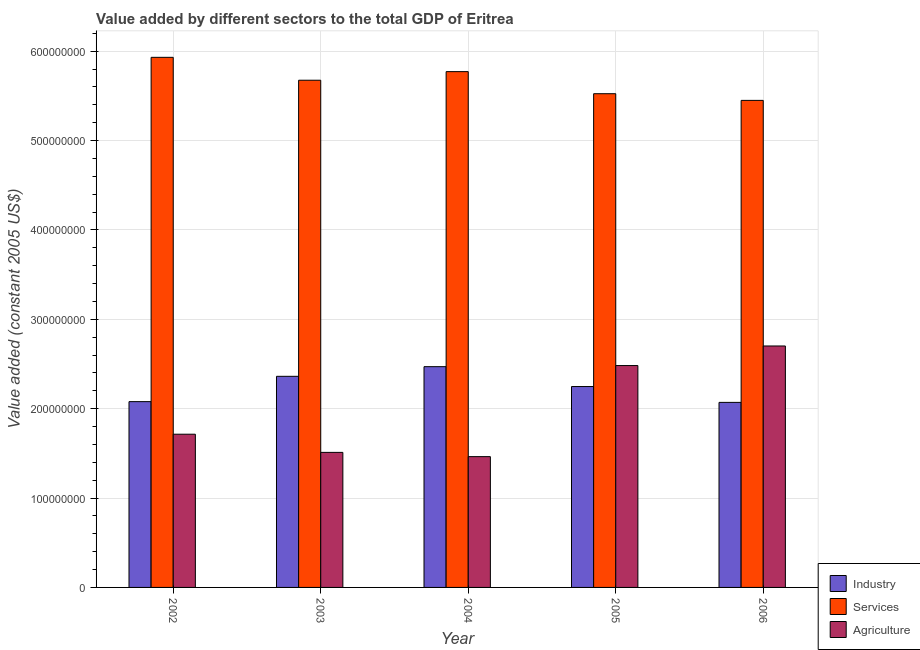How many groups of bars are there?
Give a very brief answer. 5. Are the number of bars per tick equal to the number of legend labels?
Your answer should be very brief. Yes. How many bars are there on the 1st tick from the right?
Offer a very short reply. 3. What is the value added by services in 2003?
Provide a succinct answer. 5.67e+08. Across all years, what is the maximum value added by services?
Your answer should be very brief. 5.93e+08. Across all years, what is the minimum value added by industrial sector?
Keep it short and to the point. 2.07e+08. In which year was the value added by industrial sector maximum?
Keep it short and to the point. 2004. What is the total value added by services in the graph?
Offer a terse response. 2.84e+09. What is the difference between the value added by agricultural sector in 2005 and that in 2006?
Your answer should be very brief. -2.19e+07. What is the difference between the value added by industrial sector in 2003 and the value added by agricultural sector in 2002?
Offer a terse response. 2.83e+07. What is the average value added by industrial sector per year?
Provide a succinct answer. 2.25e+08. In the year 2002, what is the difference between the value added by agricultural sector and value added by services?
Offer a terse response. 0. In how many years, is the value added by industrial sector greater than 320000000 US$?
Ensure brevity in your answer.  0. What is the ratio of the value added by agricultural sector in 2002 to that in 2005?
Keep it short and to the point. 0.69. Is the difference between the value added by agricultural sector in 2004 and 2005 greater than the difference between the value added by industrial sector in 2004 and 2005?
Keep it short and to the point. No. What is the difference between the highest and the second highest value added by industrial sector?
Provide a short and direct response. 1.08e+07. What is the difference between the highest and the lowest value added by agricultural sector?
Your response must be concise. 1.24e+08. What does the 1st bar from the left in 2004 represents?
Your answer should be compact. Industry. What does the 3rd bar from the right in 2005 represents?
Keep it short and to the point. Industry. Is it the case that in every year, the sum of the value added by industrial sector and value added by services is greater than the value added by agricultural sector?
Keep it short and to the point. Yes. Are all the bars in the graph horizontal?
Your answer should be very brief. No. What is the difference between two consecutive major ticks on the Y-axis?
Offer a terse response. 1.00e+08. Are the values on the major ticks of Y-axis written in scientific E-notation?
Keep it short and to the point. No. Does the graph contain any zero values?
Your response must be concise. No. Does the graph contain grids?
Ensure brevity in your answer.  Yes. Where does the legend appear in the graph?
Your answer should be compact. Bottom right. How many legend labels are there?
Provide a succinct answer. 3. How are the legend labels stacked?
Make the answer very short. Vertical. What is the title of the graph?
Offer a terse response. Value added by different sectors to the total GDP of Eritrea. What is the label or title of the X-axis?
Your answer should be compact. Year. What is the label or title of the Y-axis?
Offer a very short reply. Value added (constant 2005 US$). What is the Value added (constant 2005 US$) in Industry in 2002?
Offer a terse response. 2.08e+08. What is the Value added (constant 2005 US$) in Services in 2002?
Your answer should be very brief. 5.93e+08. What is the Value added (constant 2005 US$) of Agriculture in 2002?
Keep it short and to the point. 1.71e+08. What is the Value added (constant 2005 US$) in Industry in 2003?
Your answer should be very brief. 2.36e+08. What is the Value added (constant 2005 US$) of Services in 2003?
Ensure brevity in your answer.  5.67e+08. What is the Value added (constant 2005 US$) in Agriculture in 2003?
Your answer should be very brief. 1.51e+08. What is the Value added (constant 2005 US$) of Industry in 2004?
Offer a terse response. 2.47e+08. What is the Value added (constant 2005 US$) of Services in 2004?
Keep it short and to the point. 5.77e+08. What is the Value added (constant 2005 US$) of Agriculture in 2004?
Give a very brief answer. 1.46e+08. What is the Value added (constant 2005 US$) in Industry in 2005?
Ensure brevity in your answer.  2.25e+08. What is the Value added (constant 2005 US$) of Services in 2005?
Your answer should be very brief. 5.52e+08. What is the Value added (constant 2005 US$) in Agriculture in 2005?
Your answer should be very brief. 2.48e+08. What is the Value added (constant 2005 US$) in Industry in 2006?
Your answer should be compact. 2.07e+08. What is the Value added (constant 2005 US$) of Services in 2006?
Offer a very short reply. 5.45e+08. What is the Value added (constant 2005 US$) of Agriculture in 2006?
Keep it short and to the point. 2.70e+08. Across all years, what is the maximum Value added (constant 2005 US$) in Industry?
Make the answer very short. 2.47e+08. Across all years, what is the maximum Value added (constant 2005 US$) of Services?
Offer a terse response. 5.93e+08. Across all years, what is the maximum Value added (constant 2005 US$) in Agriculture?
Offer a terse response. 2.70e+08. Across all years, what is the minimum Value added (constant 2005 US$) of Industry?
Make the answer very short. 2.07e+08. Across all years, what is the minimum Value added (constant 2005 US$) of Services?
Provide a short and direct response. 5.45e+08. Across all years, what is the minimum Value added (constant 2005 US$) of Agriculture?
Keep it short and to the point. 1.46e+08. What is the total Value added (constant 2005 US$) in Industry in the graph?
Your answer should be compact. 1.12e+09. What is the total Value added (constant 2005 US$) of Services in the graph?
Your response must be concise. 2.84e+09. What is the total Value added (constant 2005 US$) of Agriculture in the graph?
Offer a terse response. 9.87e+08. What is the difference between the Value added (constant 2005 US$) of Industry in 2002 and that in 2003?
Keep it short and to the point. -2.83e+07. What is the difference between the Value added (constant 2005 US$) in Services in 2002 and that in 2003?
Keep it short and to the point. 2.56e+07. What is the difference between the Value added (constant 2005 US$) of Agriculture in 2002 and that in 2003?
Make the answer very short. 2.03e+07. What is the difference between the Value added (constant 2005 US$) of Industry in 2002 and that in 2004?
Your response must be concise. -3.91e+07. What is the difference between the Value added (constant 2005 US$) of Services in 2002 and that in 2004?
Ensure brevity in your answer.  1.60e+07. What is the difference between the Value added (constant 2005 US$) in Agriculture in 2002 and that in 2004?
Your response must be concise. 2.51e+07. What is the difference between the Value added (constant 2005 US$) in Industry in 2002 and that in 2005?
Your answer should be compact. -1.69e+07. What is the difference between the Value added (constant 2005 US$) of Services in 2002 and that in 2005?
Make the answer very short. 4.07e+07. What is the difference between the Value added (constant 2005 US$) of Agriculture in 2002 and that in 2005?
Your response must be concise. -7.68e+07. What is the difference between the Value added (constant 2005 US$) of Industry in 2002 and that in 2006?
Give a very brief answer. 8.30e+05. What is the difference between the Value added (constant 2005 US$) in Services in 2002 and that in 2006?
Your answer should be very brief. 4.82e+07. What is the difference between the Value added (constant 2005 US$) of Agriculture in 2002 and that in 2006?
Give a very brief answer. -9.87e+07. What is the difference between the Value added (constant 2005 US$) in Industry in 2003 and that in 2004?
Provide a short and direct response. -1.08e+07. What is the difference between the Value added (constant 2005 US$) in Services in 2003 and that in 2004?
Your answer should be very brief. -9.62e+06. What is the difference between the Value added (constant 2005 US$) in Agriculture in 2003 and that in 2004?
Your response must be concise. 4.76e+06. What is the difference between the Value added (constant 2005 US$) in Industry in 2003 and that in 2005?
Give a very brief answer. 1.14e+07. What is the difference between the Value added (constant 2005 US$) in Services in 2003 and that in 2005?
Offer a terse response. 1.51e+07. What is the difference between the Value added (constant 2005 US$) in Agriculture in 2003 and that in 2005?
Keep it short and to the point. -9.71e+07. What is the difference between the Value added (constant 2005 US$) of Industry in 2003 and that in 2006?
Your response must be concise. 2.92e+07. What is the difference between the Value added (constant 2005 US$) in Services in 2003 and that in 2006?
Your answer should be very brief. 2.26e+07. What is the difference between the Value added (constant 2005 US$) of Agriculture in 2003 and that in 2006?
Give a very brief answer. -1.19e+08. What is the difference between the Value added (constant 2005 US$) in Industry in 2004 and that in 2005?
Offer a very short reply. 2.22e+07. What is the difference between the Value added (constant 2005 US$) in Services in 2004 and that in 2005?
Ensure brevity in your answer.  2.47e+07. What is the difference between the Value added (constant 2005 US$) of Agriculture in 2004 and that in 2005?
Offer a very short reply. -1.02e+08. What is the difference between the Value added (constant 2005 US$) of Industry in 2004 and that in 2006?
Keep it short and to the point. 4.00e+07. What is the difference between the Value added (constant 2005 US$) in Services in 2004 and that in 2006?
Your response must be concise. 3.22e+07. What is the difference between the Value added (constant 2005 US$) of Agriculture in 2004 and that in 2006?
Your answer should be very brief. -1.24e+08. What is the difference between the Value added (constant 2005 US$) in Industry in 2005 and that in 2006?
Your response must be concise. 1.77e+07. What is the difference between the Value added (constant 2005 US$) in Services in 2005 and that in 2006?
Your answer should be compact. 7.46e+06. What is the difference between the Value added (constant 2005 US$) in Agriculture in 2005 and that in 2006?
Make the answer very short. -2.19e+07. What is the difference between the Value added (constant 2005 US$) of Industry in 2002 and the Value added (constant 2005 US$) of Services in 2003?
Ensure brevity in your answer.  -3.60e+08. What is the difference between the Value added (constant 2005 US$) in Industry in 2002 and the Value added (constant 2005 US$) in Agriculture in 2003?
Your answer should be very brief. 5.68e+07. What is the difference between the Value added (constant 2005 US$) of Services in 2002 and the Value added (constant 2005 US$) of Agriculture in 2003?
Your response must be concise. 4.42e+08. What is the difference between the Value added (constant 2005 US$) of Industry in 2002 and the Value added (constant 2005 US$) of Services in 2004?
Your answer should be compact. -3.69e+08. What is the difference between the Value added (constant 2005 US$) in Industry in 2002 and the Value added (constant 2005 US$) in Agriculture in 2004?
Offer a very short reply. 6.15e+07. What is the difference between the Value added (constant 2005 US$) of Services in 2002 and the Value added (constant 2005 US$) of Agriculture in 2004?
Your answer should be compact. 4.47e+08. What is the difference between the Value added (constant 2005 US$) in Industry in 2002 and the Value added (constant 2005 US$) in Services in 2005?
Provide a succinct answer. -3.45e+08. What is the difference between the Value added (constant 2005 US$) of Industry in 2002 and the Value added (constant 2005 US$) of Agriculture in 2005?
Give a very brief answer. -4.04e+07. What is the difference between the Value added (constant 2005 US$) in Services in 2002 and the Value added (constant 2005 US$) in Agriculture in 2005?
Your response must be concise. 3.45e+08. What is the difference between the Value added (constant 2005 US$) in Industry in 2002 and the Value added (constant 2005 US$) in Services in 2006?
Offer a very short reply. -3.37e+08. What is the difference between the Value added (constant 2005 US$) in Industry in 2002 and the Value added (constant 2005 US$) in Agriculture in 2006?
Provide a succinct answer. -6.23e+07. What is the difference between the Value added (constant 2005 US$) in Services in 2002 and the Value added (constant 2005 US$) in Agriculture in 2006?
Your answer should be very brief. 3.23e+08. What is the difference between the Value added (constant 2005 US$) of Industry in 2003 and the Value added (constant 2005 US$) of Services in 2004?
Your answer should be compact. -3.41e+08. What is the difference between the Value added (constant 2005 US$) of Industry in 2003 and the Value added (constant 2005 US$) of Agriculture in 2004?
Provide a short and direct response. 8.99e+07. What is the difference between the Value added (constant 2005 US$) in Services in 2003 and the Value added (constant 2005 US$) in Agriculture in 2004?
Provide a short and direct response. 4.21e+08. What is the difference between the Value added (constant 2005 US$) of Industry in 2003 and the Value added (constant 2005 US$) of Services in 2005?
Keep it short and to the point. -3.16e+08. What is the difference between the Value added (constant 2005 US$) in Industry in 2003 and the Value added (constant 2005 US$) in Agriculture in 2005?
Ensure brevity in your answer.  -1.20e+07. What is the difference between the Value added (constant 2005 US$) in Services in 2003 and the Value added (constant 2005 US$) in Agriculture in 2005?
Keep it short and to the point. 3.19e+08. What is the difference between the Value added (constant 2005 US$) of Industry in 2003 and the Value added (constant 2005 US$) of Services in 2006?
Your answer should be very brief. -3.09e+08. What is the difference between the Value added (constant 2005 US$) of Industry in 2003 and the Value added (constant 2005 US$) of Agriculture in 2006?
Make the answer very short. -3.39e+07. What is the difference between the Value added (constant 2005 US$) of Services in 2003 and the Value added (constant 2005 US$) of Agriculture in 2006?
Give a very brief answer. 2.97e+08. What is the difference between the Value added (constant 2005 US$) of Industry in 2004 and the Value added (constant 2005 US$) of Services in 2005?
Give a very brief answer. -3.05e+08. What is the difference between the Value added (constant 2005 US$) of Industry in 2004 and the Value added (constant 2005 US$) of Agriculture in 2005?
Ensure brevity in your answer.  -1.25e+06. What is the difference between the Value added (constant 2005 US$) in Services in 2004 and the Value added (constant 2005 US$) in Agriculture in 2005?
Your answer should be very brief. 3.29e+08. What is the difference between the Value added (constant 2005 US$) in Industry in 2004 and the Value added (constant 2005 US$) in Services in 2006?
Your response must be concise. -2.98e+08. What is the difference between the Value added (constant 2005 US$) in Industry in 2004 and the Value added (constant 2005 US$) in Agriculture in 2006?
Your answer should be very brief. -2.31e+07. What is the difference between the Value added (constant 2005 US$) of Services in 2004 and the Value added (constant 2005 US$) of Agriculture in 2006?
Keep it short and to the point. 3.07e+08. What is the difference between the Value added (constant 2005 US$) of Industry in 2005 and the Value added (constant 2005 US$) of Services in 2006?
Your answer should be very brief. -3.20e+08. What is the difference between the Value added (constant 2005 US$) of Industry in 2005 and the Value added (constant 2005 US$) of Agriculture in 2006?
Your response must be concise. -4.54e+07. What is the difference between the Value added (constant 2005 US$) of Services in 2005 and the Value added (constant 2005 US$) of Agriculture in 2006?
Offer a terse response. 2.82e+08. What is the average Value added (constant 2005 US$) of Industry per year?
Your answer should be compact. 2.25e+08. What is the average Value added (constant 2005 US$) in Services per year?
Your answer should be compact. 5.67e+08. What is the average Value added (constant 2005 US$) of Agriculture per year?
Keep it short and to the point. 1.97e+08. In the year 2002, what is the difference between the Value added (constant 2005 US$) of Industry and Value added (constant 2005 US$) of Services?
Make the answer very short. -3.85e+08. In the year 2002, what is the difference between the Value added (constant 2005 US$) in Industry and Value added (constant 2005 US$) in Agriculture?
Offer a terse response. 3.65e+07. In the year 2002, what is the difference between the Value added (constant 2005 US$) in Services and Value added (constant 2005 US$) in Agriculture?
Give a very brief answer. 4.22e+08. In the year 2003, what is the difference between the Value added (constant 2005 US$) of Industry and Value added (constant 2005 US$) of Services?
Keep it short and to the point. -3.31e+08. In the year 2003, what is the difference between the Value added (constant 2005 US$) in Industry and Value added (constant 2005 US$) in Agriculture?
Your answer should be compact. 8.51e+07. In the year 2003, what is the difference between the Value added (constant 2005 US$) of Services and Value added (constant 2005 US$) of Agriculture?
Keep it short and to the point. 4.16e+08. In the year 2004, what is the difference between the Value added (constant 2005 US$) of Industry and Value added (constant 2005 US$) of Services?
Ensure brevity in your answer.  -3.30e+08. In the year 2004, what is the difference between the Value added (constant 2005 US$) in Industry and Value added (constant 2005 US$) in Agriculture?
Your response must be concise. 1.01e+08. In the year 2004, what is the difference between the Value added (constant 2005 US$) of Services and Value added (constant 2005 US$) of Agriculture?
Your answer should be very brief. 4.31e+08. In the year 2005, what is the difference between the Value added (constant 2005 US$) of Industry and Value added (constant 2005 US$) of Services?
Your response must be concise. -3.28e+08. In the year 2005, what is the difference between the Value added (constant 2005 US$) of Industry and Value added (constant 2005 US$) of Agriculture?
Provide a succinct answer. -2.35e+07. In the year 2005, what is the difference between the Value added (constant 2005 US$) in Services and Value added (constant 2005 US$) in Agriculture?
Provide a succinct answer. 3.04e+08. In the year 2006, what is the difference between the Value added (constant 2005 US$) in Industry and Value added (constant 2005 US$) in Services?
Your answer should be very brief. -3.38e+08. In the year 2006, what is the difference between the Value added (constant 2005 US$) in Industry and Value added (constant 2005 US$) in Agriculture?
Offer a very short reply. -6.31e+07. In the year 2006, what is the difference between the Value added (constant 2005 US$) of Services and Value added (constant 2005 US$) of Agriculture?
Your answer should be very brief. 2.75e+08. What is the ratio of the Value added (constant 2005 US$) of Industry in 2002 to that in 2003?
Provide a succinct answer. 0.88. What is the ratio of the Value added (constant 2005 US$) in Services in 2002 to that in 2003?
Make the answer very short. 1.05. What is the ratio of the Value added (constant 2005 US$) in Agriculture in 2002 to that in 2003?
Provide a short and direct response. 1.13. What is the ratio of the Value added (constant 2005 US$) of Industry in 2002 to that in 2004?
Give a very brief answer. 0.84. What is the ratio of the Value added (constant 2005 US$) in Services in 2002 to that in 2004?
Provide a succinct answer. 1.03. What is the ratio of the Value added (constant 2005 US$) in Agriculture in 2002 to that in 2004?
Your answer should be compact. 1.17. What is the ratio of the Value added (constant 2005 US$) of Industry in 2002 to that in 2005?
Your answer should be very brief. 0.92. What is the ratio of the Value added (constant 2005 US$) in Services in 2002 to that in 2005?
Provide a succinct answer. 1.07. What is the ratio of the Value added (constant 2005 US$) of Agriculture in 2002 to that in 2005?
Provide a succinct answer. 0.69. What is the ratio of the Value added (constant 2005 US$) in Industry in 2002 to that in 2006?
Your answer should be very brief. 1. What is the ratio of the Value added (constant 2005 US$) in Services in 2002 to that in 2006?
Provide a succinct answer. 1.09. What is the ratio of the Value added (constant 2005 US$) of Agriculture in 2002 to that in 2006?
Provide a short and direct response. 0.63. What is the ratio of the Value added (constant 2005 US$) of Industry in 2003 to that in 2004?
Make the answer very short. 0.96. What is the ratio of the Value added (constant 2005 US$) of Services in 2003 to that in 2004?
Offer a terse response. 0.98. What is the ratio of the Value added (constant 2005 US$) in Agriculture in 2003 to that in 2004?
Offer a very short reply. 1.03. What is the ratio of the Value added (constant 2005 US$) of Industry in 2003 to that in 2005?
Your answer should be very brief. 1.05. What is the ratio of the Value added (constant 2005 US$) in Services in 2003 to that in 2005?
Keep it short and to the point. 1.03. What is the ratio of the Value added (constant 2005 US$) of Agriculture in 2003 to that in 2005?
Provide a short and direct response. 0.61. What is the ratio of the Value added (constant 2005 US$) in Industry in 2003 to that in 2006?
Provide a short and direct response. 1.14. What is the ratio of the Value added (constant 2005 US$) of Services in 2003 to that in 2006?
Give a very brief answer. 1.04. What is the ratio of the Value added (constant 2005 US$) in Agriculture in 2003 to that in 2006?
Your answer should be very brief. 0.56. What is the ratio of the Value added (constant 2005 US$) in Industry in 2004 to that in 2005?
Give a very brief answer. 1.1. What is the ratio of the Value added (constant 2005 US$) of Services in 2004 to that in 2005?
Your response must be concise. 1.04. What is the ratio of the Value added (constant 2005 US$) in Agriculture in 2004 to that in 2005?
Keep it short and to the point. 0.59. What is the ratio of the Value added (constant 2005 US$) in Industry in 2004 to that in 2006?
Keep it short and to the point. 1.19. What is the ratio of the Value added (constant 2005 US$) of Services in 2004 to that in 2006?
Your response must be concise. 1.06. What is the ratio of the Value added (constant 2005 US$) in Agriculture in 2004 to that in 2006?
Provide a short and direct response. 0.54. What is the ratio of the Value added (constant 2005 US$) of Industry in 2005 to that in 2006?
Provide a succinct answer. 1.09. What is the ratio of the Value added (constant 2005 US$) of Services in 2005 to that in 2006?
Offer a terse response. 1.01. What is the ratio of the Value added (constant 2005 US$) of Agriculture in 2005 to that in 2006?
Your answer should be compact. 0.92. What is the difference between the highest and the second highest Value added (constant 2005 US$) in Industry?
Make the answer very short. 1.08e+07. What is the difference between the highest and the second highest Value added (constant 2005 US$) in Services?
Provide a short and direct response. 1.60e+07. What is the difference between the highest and the second highest Value added (constant 2005 US$) of Agriculture?
Ensure brevity in your answer.  2.19e+07. What is the difference between the highest and the lowest Value added (constant 2005 US$) of Industry?
Make the answer very short. 4.00e+07. What is the difference between the highest and the lowest Value added (constant 2005 US$) of Services?
Ensure brevity in your answer.  4.82e+07. What is the difference between the highest and the lowest Value added (constant 2005 US$) in Agriculture?
Offer a very short reply. 1.24e+08. 